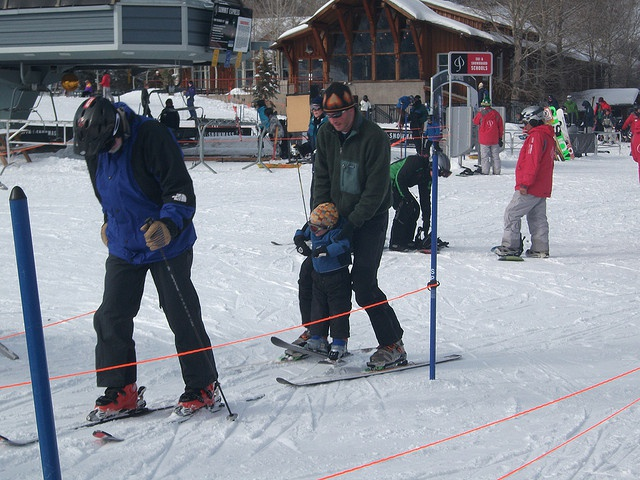Describe the objects in this image and their specific colors. I can see people in black, navy, gray, and maroon tones, people in purple, black, gray, and lightgray tones, people in purple, black, gray, navy, and lightgray tones, people in purple, black, navy, gray, and darkblue tones, and people in black, gray, brown, and darkgray tones in this image. 